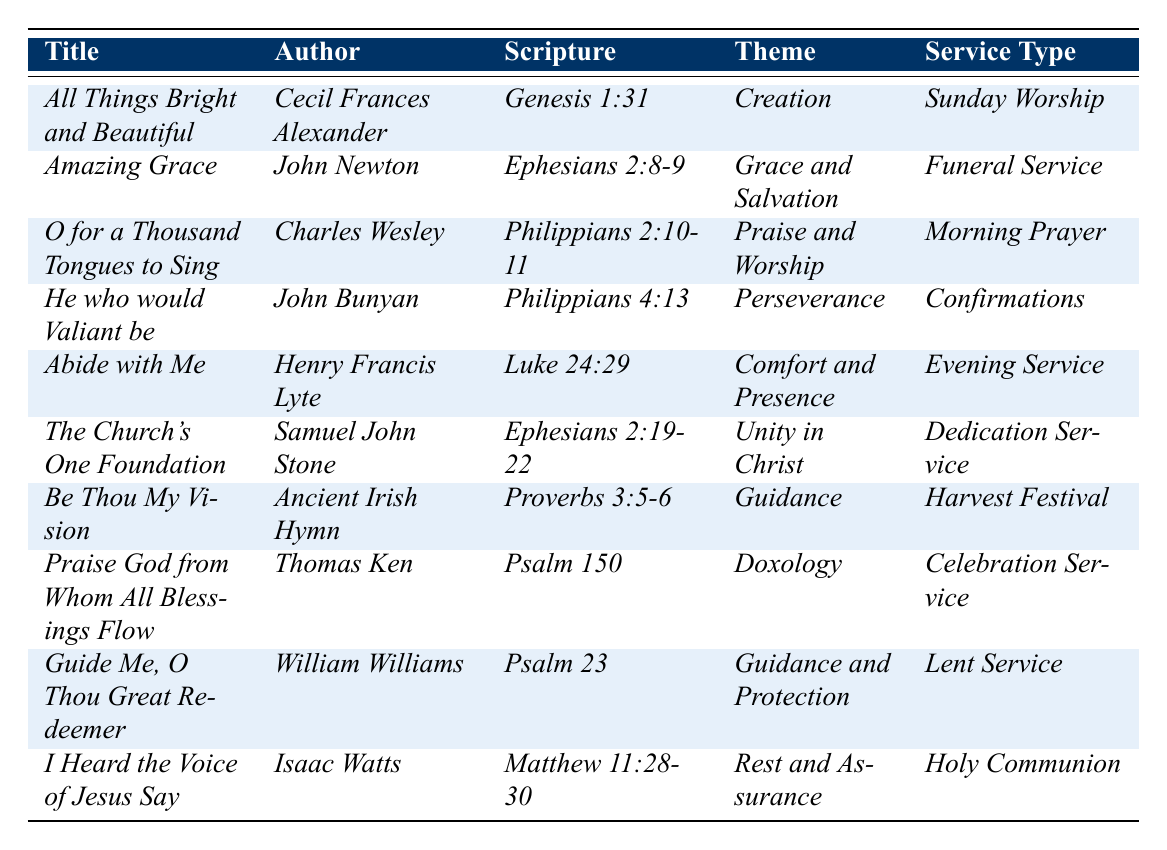What is the title of the hymn written by John Newton? The table lists the hymn written by John Newton as "Amazing Grace."
Answer: Amazing Grace Which hymn is associated with the scripture reference Genesis 1:31? The hymn associated with Genesis 1:31 is "All Things Bright and Beautiful."
Answer: All Things Bright and Beautiful How many hymns are listed for Evening Service? There is one hymn listed for Evening Service, which is "Abide with Me."
Answer: 1 What theme connects both "He who would Valiant be" and "Guide Me, O Thou Great Redeemer"? The theme of "He who would Valiant be" is Perseverance, and for "Guide Me, O Thou Great Redeemer," it is Guidance and Protection. They are not directly connected by a common theme.
Answer: No common theme Which author has hymns featured for both Lenten and Dedication Services? William Williams authored "Guide Me, O Thou Great Redeemer" for Lent Service, while Samuel John Stone wrote "The Church's One Foundation" for Dedication Service. Thus, no author has hymns for both services.
Answer: None What is the total number of unique service types mentioned in the table? The service types listed are Sunday Worship, Funeral Service, Morning Prayer, Confirmations, Evening Service, Dedication Service, Harvest Festival, Celebration Service, Lent Service, and Holy Communion, totaling 10 unique service types.
Answer: 10 Identify the hymn with the theme of "Comfort and Presence." The hymn with the theme "Comfort and Presence" is "Abide with Me."
Answer: Abide with Me What is the scripture reference for "The Church's One Foundation"? The scripture reference for "The Church's One Foundation" is Ephesians 2:19-22.
Answer: Ephesians 2:19-22 Is there a hymn that focuses on the theme of "Doxology"? Yes, "Praise God from Whom All Blessings Flow" focuses on the theme of Doxology.
Answer: Yes Which hymn has the same theme as "Amazing Grace"? The hymn "Amazing Grace" has the theme of "Grace and Salvation." No other hymn listed shares this specific theme.
Answer: None Based on the table, how many hymns are associated with themes related to guidance? There are two hymns associated with guidance: "Be Thou My Vision" and "Guide Me, O Thou Great Redeemer."
Answer: 2 